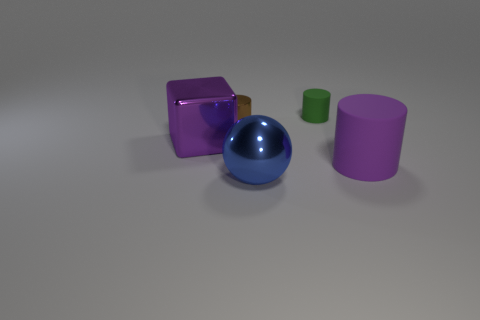What is the material of the cube that is the same color as the big cylinder?
Provide a short and direct response. Metal. How many things are objects that are in front of the purple shiny block or large purple metallic blocks?
Your answer should be very brief. 3. Is the size of the rubber object that is in front of the brown thing the same as the green rubber object?
Offer a terse response. No. Are there fewer tiny matte objects that are on the left side of the shiny ball than purple rubber cylinders?
Give a very brief answer. Yes. There is a green object that is the same size as the brown cylinder; what material is it?
Offer a very short reply. Rubber. What number of big objects are rubber objects or blue balls?
Your response must be concise. 2. What number of things are either purple objects that are to the left of the large blue object or things that are right of the block?
Your answer should be compact. 5. Are there fewer large green balls than tiny brown cylinders?
Offer a very short reply. Yes. There is a shiny object that is the same size as the blue ball; what is its shape?
Provide a succinct answer. Cube. What number of other objects are the same color as the small metal object?
Your response must be concise. 0. 